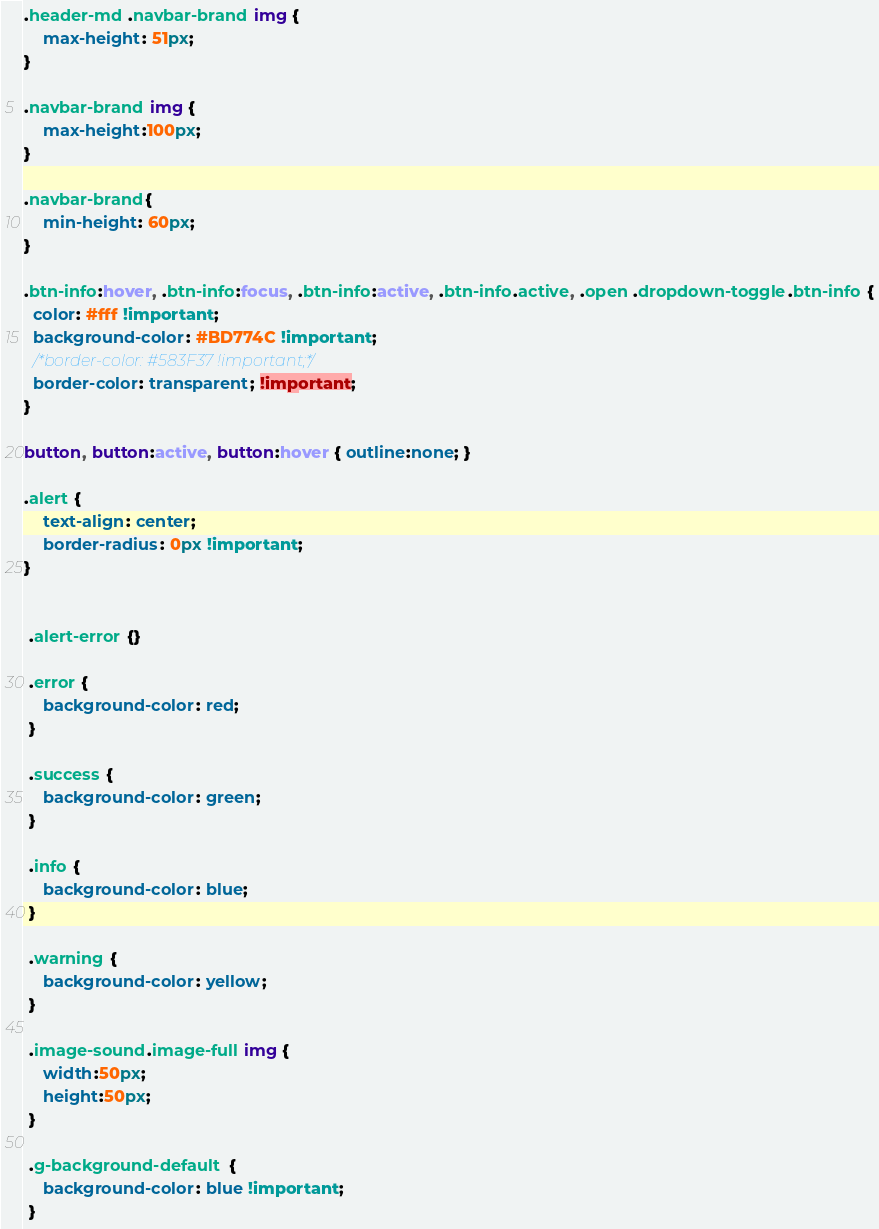<code> <loc_0><loc_0><loc_500><loc_500><_CSS_>.header-md .navbar-brand img {
	max-height: 51px;
}

.navbar-brand img {
	max-height:100px;
}

.navbar-brand{
	min-height: 60px;
}

.btn-info:hover, .btn-info:focus, .btn-info:active, .btn-info.active, .open .dropdown-toggle.btn-info {
  color: #fff !important;
  background-color: #BD774C !important;
  /*border-color: #583F37 !important;*/
  border-color: transparent; !important;
}

button, button:active, button:hover { outline:none; }

.alert {
	text-align: center;
	border-radius: 0px !important;
}


 .alert-error {}

 .error {
 	background-color: red;
 }

 .success {
 	background-color: green;
 }

 .info {
 	background-color: blue;
 }

 .warning {
 	background-color: yellow;
 }

 .image-sound.image-full img {
 	width:50px;
 	height:50px;
 }

 .g-background-default {
 	background-color: blue !important;
 }</code> 